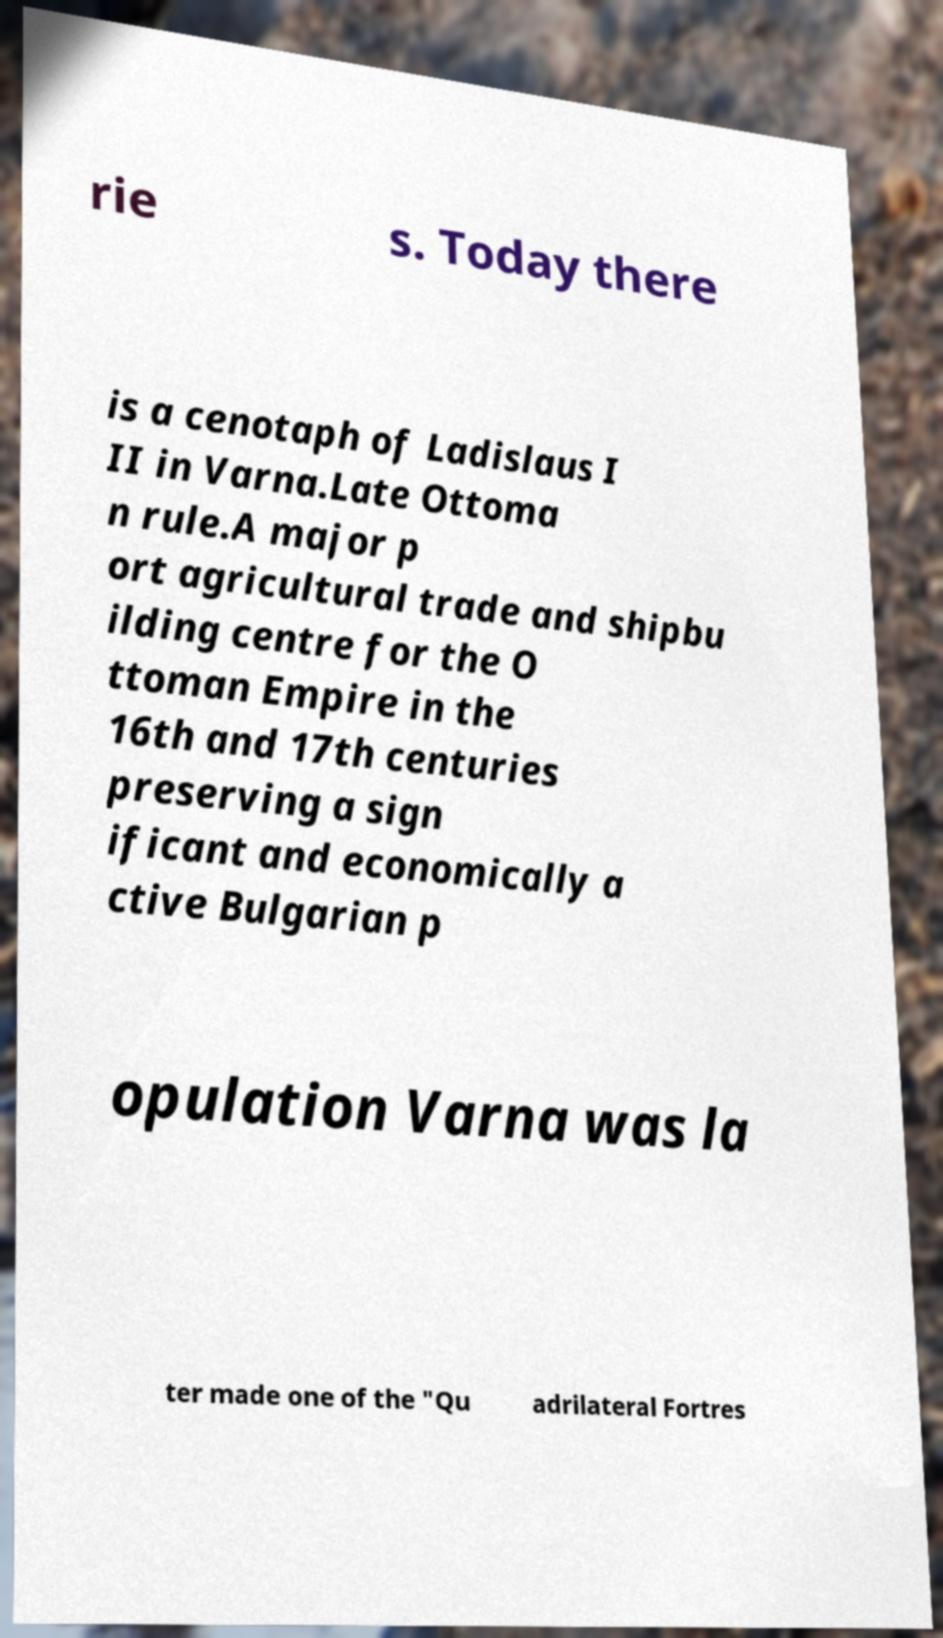Please read and relay the text visible in this image. What does it say? rie s. Today there is a cenotaph of Ladislaus I II in Varna.Late Ottoma n rule.A major p ort agricultural trade and shipbu ilding centre for the O ttoman Empire in the 16th and 17th centuries preserving a sign ificant and economically a ctive Bulgarian p opulation Varna was la ter made one of the "Qu adrilateral Fortres 